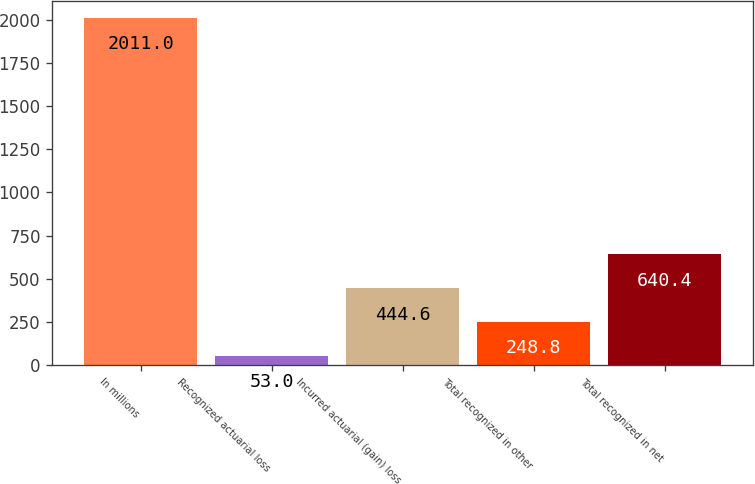Convert chart to OTSL. <chart><loc_0><loc_0><loc_500><loc_500><bar_chart><fcel>In millions<fcel>Recognized actuarial loss<fcel>Incurred actuarial (gain) loss<fcel>Total recognized in other<fcel>Total recognized in net<nl><fcel>2011<fcel>53<fcel>444.6<fcel>248.8<fcel>640.4<nl></chart> 